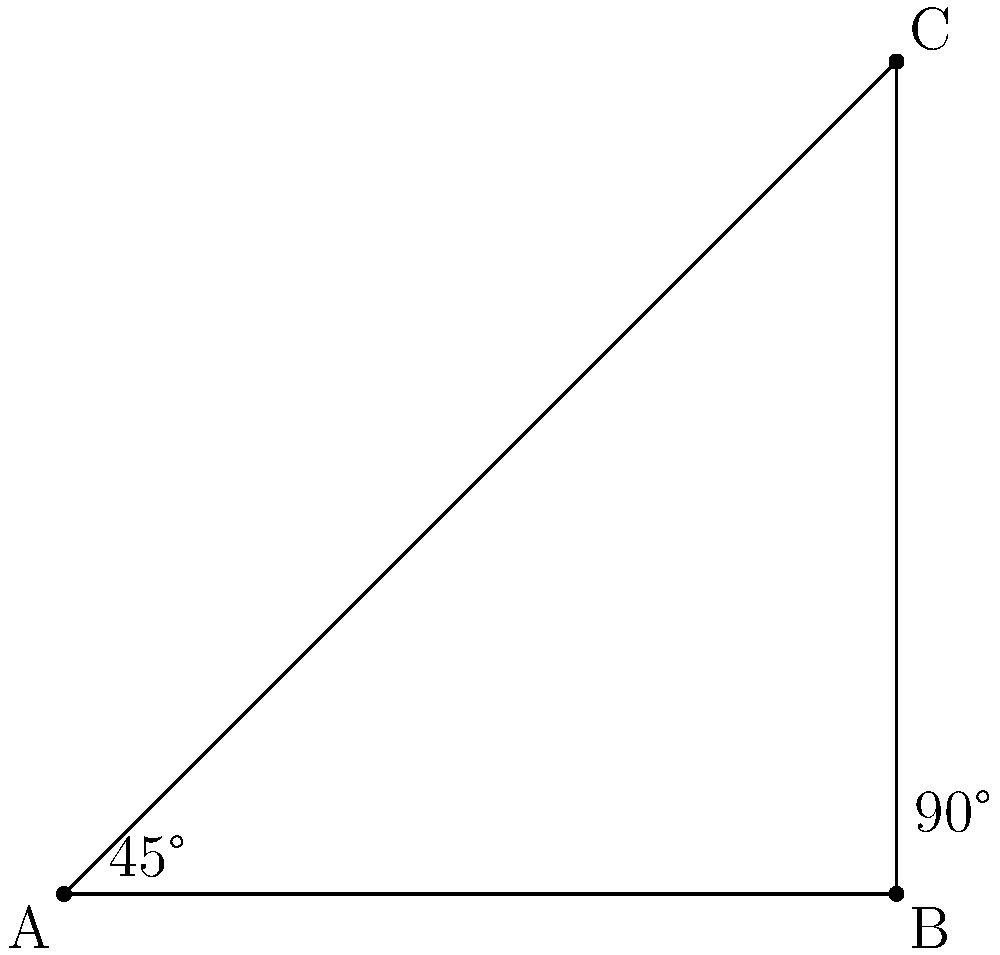During a stretching session in the park, you notice a participant forming a right-angled triangle with their arm and torso. If the angle between their arm and the ground is 45°, what is the angle formed between their arm and torso? Let's approach this step-by-step:

1) In a right-angled triangle, the sum of all angles is 180°.

2) We know that one angle is 90° (the right angle between the ground and the torso).

3) We're given that the angle between the arm and the ground is 45°.

4) Let's call the angle between the arm and torso $x$.

5) We can set up an equation:
   $90° + 45° + x = 180°$

6) Simplifying:
   $135° + x = 180°$

7) Subtracting 135° from both sides:
   $x = 180° - 135° = 45°$

Therefore, the angle formed between the arm and torso is 45°.
Answer: 45° 